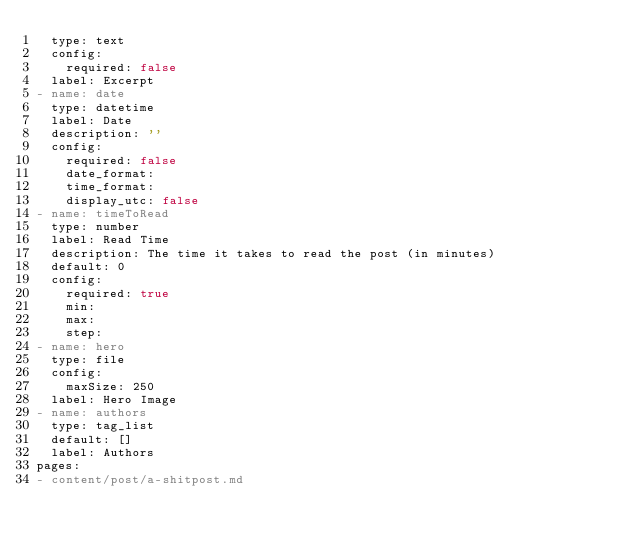Convert code to text. <code><loc_0><loc_0><loc_500><loc_500><_YAML_>  type: text
  config:
    required: false
  label: Excerpt
- name: date
  type: datetime
  label: Date
  description: ''
  config:
    required: false
    date_format: 
    time_format: 
    display_utc: false
- name: timeToRead
  type: number
  label: Read Time
  description: The time it takes to read the post (in minutes)
  default: 0
  config:
    required: true
    min: 
    max: 
    step: 
- name: hero
  type: file
  config:
    maxSize: 250
  label: Hero Image
- name: authors
  type: tag_list
  default: []
  label: Authors
pages:
- content/post/a-shitpost.md
</code> 